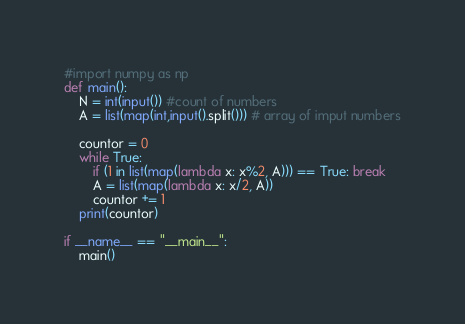Convert code to text. <code><loc_0><loc_0><loc_500><loc_500><_Python_>#import numpy as np
def main():
    N = int(input()) #count of numbers
    A = list(map(int,input().split())) # array of imput numbers

    countor = 0
    while True:
        if (1 in list(map(lambda x: x%2, A))) == True: break
        A = list(map(lambda x: x/2, A))
        countor += 1
    print(countor)

if __name__ == "__main__":
    main()</code> 